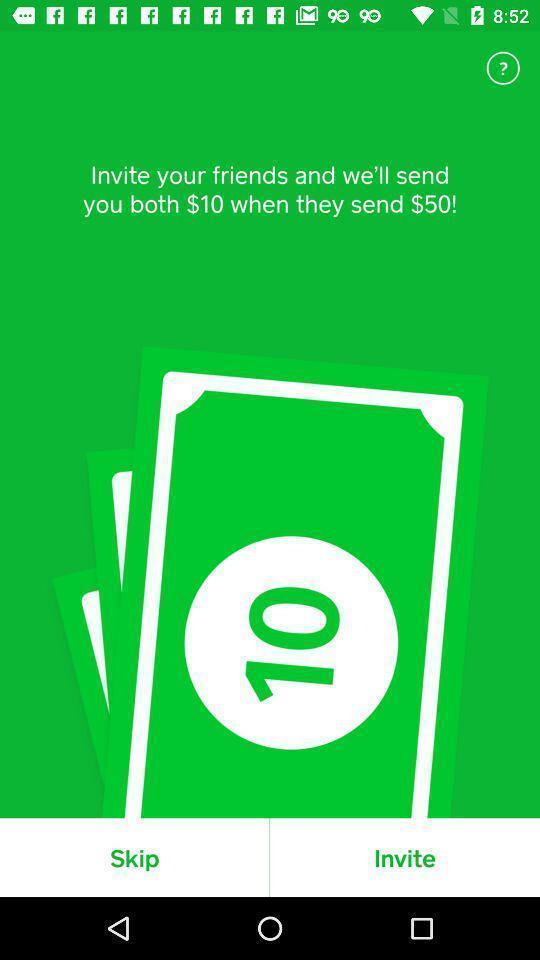Give me a narrative description of this picture. Page with skip and invite option. 